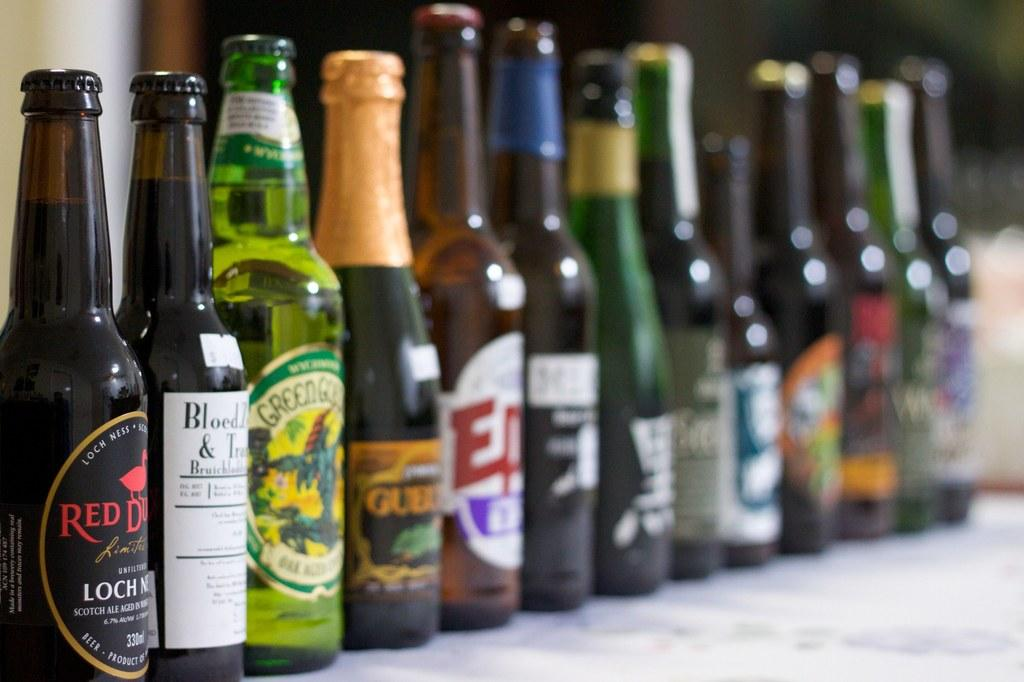<image>
Create a compact narrative representing the image presented. A bottle of Red Duck Loch Ness beer sitting next to other alcoholic beverages 